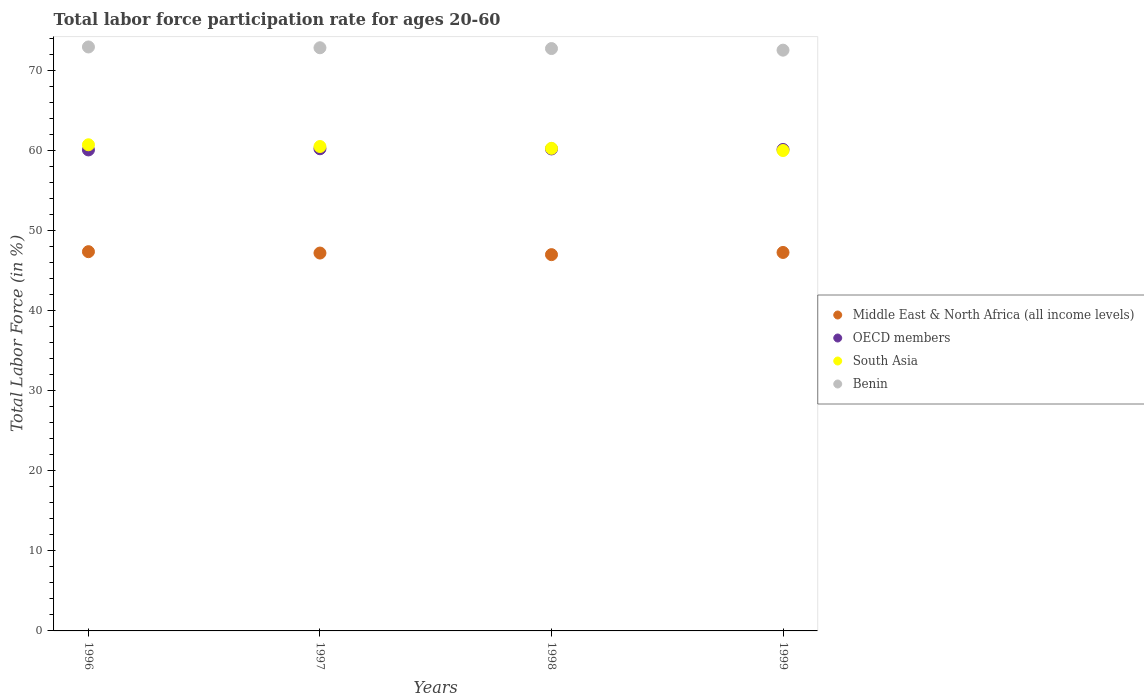What is the labor force participation rate in Middle East & North Africa (all income levels) in 1997?
Offer a very short reply. 47.17. Across all years, what is the maximum labor force participation rate in OECD members?
Your response must be concise. 60.19. Across all years, what is the minimum labor force participation rate in Middle East & North Africa (all income levels)?
Make the answer very short. 46.97. In which year was the labor force participation rate in OECD members maximum?
Ensure brevity in your answer.  1997. What is the total labor force participation rate in Middle East & North Africa (all income levels) in the graph?
Your answer should be very brief. 188.74. What is the difference between the labor force participation rate in Benin in 1996 and that in 1997?
Make the answer very short. 0.1. What is the difference between the labor force participation rate in OECD members in 1997 and the labor force participation rate in Middle East & North Africa (all income levels) in 1999?
Make the answer very short. 12.94. What is the average labor force participation rate in South Asia per year?
Offer a very short reply. 60.34. In the year 1999, what is the difference between the labor force participation rate in OECD members and labor force participation rate in Middle East & North Africa (all income levels)?
Provide a succinct answer. 12.86. In how many years, is the labor force participation rate in Middle East & North Africa (all income levels) greater than 36 %?
Provide a short and direct response. 4. What is the ratio of the labor force participation rate in Benin in 1997 to that in 1998?
Offer a very short reply. 1. Is the labor force participation rate in Middle East & North Africa (all income levels) in 1998 less than that in 1999?
Your response must be concise. Yes. Is the difference between the labor force participation rate in OECD members in 1997 and 1999 greater than the difference between the labor force participation rate in Middle East & North Africa (all income levels) in 1997 and 1999?
Ensure brevity in your answer.  Yes. What is the difference between the highest and the second highest labor force participation rate in Middle East & North Africa (all income levels)?
Your answer should be very brief. 0.1. What is the difference between the highest and the lowest labor force participation rate in Middle East & North Africa (all income levels)?
Provide a short and direct response. 0.37. Is it the case that in every year, the sum of the labor force participation rate in Benin and labor force participation rate in South Asia  is greater than the sum of labor force participation rate in Middle East & North Africa (all income levels) and labor force participation rate in OECD members?
Offer a terse response. Yes. Is it the case that in every year, the sum of the labor force participation rate in South Asia and labor force participation rate in OECD members  is greater than the labor force participation rate in Middle East & North Africa (all income levels)?
Offer a terse response. Yes. Does the labor force participation rate in OECD members monotonically increase over the years?
Keep it short and to the point. No. Is the labor force participation rate in Middle East & North Africa (all income levels) strictly greater than the labor force participation rate in Benin over the years?
Your answer should be very brief. No. Is the labor force participation rate in South Asia strictly less than the labor force participation rate in Middle East & North Africa (all income levels) over the years?
Make the answer very short. No. How many dotlines are there?
Provide a succinct answer. 4. How many years are there in the graph?
Make the answer very short. 4. What is the difference between two consecutive major ticks on the Y-axis?
Give a very brief answer. 10. What is the title of the graph?
Your answer should be compact. Total labor force participation rate for ages 20-60. Does "Bolivia" appear as one of the legend labels in the graph?
Keep it short and to the point. No. What is the label or title of the X-axis?
Offer a terse response. Years. What is the label or title of the Y-axis?
Your response must be concise. Total Labor Force (in %). What is the Total Labor Force (in %) of Middle East & North Africa (all income levels) in 1996?
Your answer should be very brief. 47.34. What is the Total Labor Force (in %) of OECD members in 1996?
Provide a succinct answer. 60.05. What is the Total Labor Force (in %) of South Asia in 1996?
Provide a succinct answer. 60.69. What is the Total Labor Force (in %) of Benin in 1996?
Give a very brief answer. 72.9. What is the Total Labor Force (in %) of Middle East & North Africa (all income levels) in 1997?
Provide a succinct answer. 47.17. What is the Total Labor Force (in %) in OECD members in 1997?
Provide a short and direct response. 60.19. What is the Total Labor Force (in %) of South Asia in 1997?
Your answer should be very brief. 60.47. What is the Total Labor Force (in %) of Benin in 1997?
Give a very brief answer. 72.8. What is the Total Labor Force (in %) in Middle East & North Africa (all income levels) in 1998?
Provide a succinct answer. 46.97. What is the Total Labor Force (in %) of OECD members in 1998?
Your response must be concise. 60.17. What is the Total Labor Force (in %) in South Asia in 1998?
Give a very brief answer. 60.25. What is the Total Labor Force (in %) in Benin in 1998?
Provide a succinct answer. 72.7. What is the Total Labor Force (in %) of Middle East & North Africa (all income levels) in 1999?
Ensure brevity in your answer.  47.25. What is the Total Labor Force (in %) in OECD members in 1999?
Your answer should be very brief. 60.1. What is the Total Labor Force (in %) of South Asia in 1999?
Your answer should be compact. 59.97. What is the Total Labor Force (in %) in Benin in 1999?
Your answer should be very brief. 72.5. Across all years, what is the maximum Total Labor Force (in %) of Middle East & North Africa (all income levels)?
Give a very brief answer. 47.34. Across all years, what is the maximum Total Labor Force (in %) of OECD members?
Give a very brief answer. 60.19. Across all years, what is the maximum Total Labor Force (in %) in South Asia?
Your response must be concise. 60.69. Across all years, what is the maximum Total Labor Force (in %) of Benin?
Offer a terse response. 72.9. Across all years, what is the minimum Total Labor Force (in %) in Middle East & North Africa (all income levels)?
Your answer should be very brief. 46.97. Across all years, what is the minimum Total Labor Force (in %) in OECD members?
Keep it short and to the point. 60.05. Across all years, what is the minimum Total Labor Force (in %) in South Asia?
Your answer should be compact. 59.97. Across all years, what is the minimum Total Labor Force (in %) of Benin?
Keep it short and to the point. 72.5. What is the total Total Labor Force (in %) in Middle East & North Africa (all income levels) in the graph?
Your answer should be compact. 188.74. What is the total Total Labor Force (in %) in OECD members in the graph?
Provide a succinct answer. 240.51. What is the total Total Labor Force (in %) of South Asia in the graph?
Provide a short and direct response. 241.38. What is the total Total Labor Force (in %) in Benin in the graph?
Provide a short and direct response. 290.9. What is the difference between the Total Labor Force (in %) in Middle East & North Africa (all income levels) in 1996 and that in 1997?
Provide a short and direct response. 0.17. What is the difference between the Total Labor Force (in %) of OECD members in 1996 and that in 1997?
Offer a terse response. -0.15. What is the difference between the Total Labor Force (in %) of South Asia in 1996 and that in 1997?
Ensure brevity in your answer.  0.22. What is the difference between the Total Labor Force (in %) in Benin in 1996 and that in 1997?
Your answer should be very brief. 0.1. What is the difference between the Total Labor Force (in %) of Middle East & North Africa (all income levels) in 1996 and that in 1998?
Your response must be concise. 0.37. What is the difference between the Total Labor Force (in %) of OECD members in 1996 and that in 1998?
Your answer should be compact. -0.12. What is the difference between the Total Labor Force (in %) in South Asia in 1996 and that in 1998?
Offer a very short reply. 0.44. What is the difference between the Total Labor Force (in %) in Middle East & North Africa (all income levels) in 1996 and that in 1999?
Your answer should be very brief. 0.1. What is the difference between the Total Labor Force (in %) of OECD members in 1996 and that in 1999?
Offer a terse response. -0.06. What is the difference between the Total Labor Force (in %) in South Asia in 1996 and that in 1999?
Ensure brevity in your answer.  0.72. What is the difference between the Total Labor Force (in %) of Middle East & North Africa (all income levels) in 1997 and that in 1998?
Your answer should be compact. 0.2. What is the difference between the Total Labor Force (in %) of OECD members in 1997 and that in 1998?
Your answer should be very brief. 0.02. What is the difference between the Total Labor Force (in %) of South Asia in 1997 and that in 1998?
Ensure brevity in your answer.  0.23. What is the difference between the Total Labor Force (in %) of Benin in 1997 and that in 1998?
Ensure brevity in your answer.  0.1. What is the difference between the Total Labor Force (in %) of Middle East & North Africa (all income levels) in 1997 and that in 1999?
Your answer should be compact. -0.07. What is the difference between the Total Labor Force (in %) of OECD members in 1997 and that in 1999?
Offer a very short reply. 0.09. What is the difference between the Total Labor Force (in %) in South Asia in 1997 and that in 1999?
Your answer should be compact. 0.5. What is the difference between the Total Labor Force (in %) of Benin in 1997 and that in 1999?
Give a very brief answer. 0.3. What is the difference between the Total Labor Force (in %) of Middle East & North Africa (all income levels) in 1998 and that in 1999?
Your answer should be very brief. -0.27. What is the difference between the Total Labor Force (in %) in OECD members in 1998 and that in 1999?
Give a very brief answer. 0.06. What is the difference between the Total Labor Force (in %) in South Asia in 1998 and that in 1999?
Give a very brief answer. 0.27. What is the difference between the Total Labor Force (in %) of Middle East & North Africa (all income levels) in 1996 and the Total Labor Force (in %) of OECD members in 1997?
Offer a very short reply. -12.85. What is the difference between the Total Labor Force (in %) of Middle East & North Africa (all income levels) in 1996 and the Total Labor Force (in %) of South Asia in 1997?
Provide a succinct answer. -13.13. What is the difference between the Total Labor Force (in %) of Middle East & North Africa (all income levels) in 1996 and the Total Labor Force (in %) of Benin in 1997?
Make the answer very short. -25.46. What is the difference between the Total Labor Force (in %) in OECD members in 1996 and the Total Labor Force (in %) in South Asia in 1997?
Your answer should be compact. -0.43. What is the difference between the Total Labor Force (in %) in OECD members in 1996 and the Total Labor Force (in %) in Benin in 1997?
Your answer should be very brief. -12.75. What is the difference between the Total Labor Force (in %) of South Asia in 1996 and the Total Labor Force (in %) of Benin in 1997?
Make the answer very short. -12.11. What is the difference between the Total Labor Force (in %) of Middle East & North Africa (all income levels) in 1996 and the Total Labor Force (in %) of OECD members in 1998?
Your answer should be very brief. -12.82. What is the difference between the Total Labor Force (in %) in Middle East & North Africa (all income levels) in 1996 and the Total Labor Force (in %) in South Asia in 1998?
Your answer should be very brief. -12.9. What is the difference between the Total Labor Force (in %) of Middle East & North Africa (all income levels) in 1996 and the Total Labor Force (in %) of Benin in 1998?
Your response must be concise. -25.36. What is the difference between the Total Labor Force (in %) in OECD members in 1996 and the Total Labor Force (in %) in South Asia in 1998?
Provide a short and direct response. -0.2. What is the difference between the Total Labor Force (in %) of OECD members in 1996 and the Total Labor Force (in %) of Benin in 1998?
Ensure brevity in your answer.  -12.65. What is the difference between the Total Labor Force (in %) of South Asia in 1996 and the Total Labor Force (in %) of Benin in 1998?
Make the answer very short. -12.01. What is the difference between the Total Labor Force (in %) of Middle East & North Africa (all income levels) in 1996 and the Total Labor Force (in %) of OECD members in 1999?
Offer a very short reply. -12.76. What is the difference between the Total Labor Force (in %) of Middle East & North Africa (all income levels) in 1996 and the Total Labor Force (in %) of South Asia in 1999?
Your answer should be very brief. -12.63. What is the difference between the Total Labor Force (in %) in Middle East & North Africa (all income levels) in 1996 and the Total Labor Force (in %) in Benin in 1999?
Your answer should be very brief. -25.16. What is the difference between the Total Labor Force (in %) of OECD members in 1996 and the Total Labor Force (in %) of South Asia in 1999?
Keep it short and to the point. 0.07. What is the difference between the Total Labor Force (in %) of OECD members in 1996 and the Total Labor Force (in %) of Benin in 1999?
Offer a terse response. -12.45. What is the difference between the Total Labor Force (in %) in South Asia in 1996 and the Total Labor Force (in %) in Benin in 1999?
Your answer should be very brief. -11.81. What is the difference between the Total Labor Force (in %) of Middle East & North Africa (all income levels) in 1997 and the Total Labor Force (in %) of OECD members in 1998?
Your answer should be very brief. -13. What is the difference between the Total Labor Force (in %) in Middle East & North Africa (all income levels) in 1997 and the Total Labor Force (in %) in South Asia in 1998?
Give a very brief answer. -13.07. What is the difference between the Total Labor Force (in %) in Middle East & North Africa (all income levels) in 1997 and the Total Labor Force (in %) in Benin in 1998?
Provide a short and direct response. -25.53. What is the difference between the Total Labor Force (in %) in OECD members in 1997 and the Total Labor Force (in %) in South Asia in 1998?
Your answer should be compact. -0.05. What is the difference between the Total Labor Force (in %) in OECD members in 1997 and the Total Labor Force (in %) in Benin in 1998?
Give a very brief answer. -12.51. What is the difference between the Total Labor Force (in %) in South Asia in 1997 and the Total Labor Force (in %) in Benin in 1998?
Provide a short and direct response. -12.23. What is the difference between the Total Labor Force (in %) in Middle East & North Africa (all income levels) in 1997 and the Total Labor Force (in %) in OECD members in 1999?
Provide a short and direct response. -12.93. What is the difference between the Total Labor Force (in %) in Middle East & North Africa (all income levels) in 1997 and the Total Labor Force (in %) in South Asia in 1999?
Your answer should be very brief. -12.8. What is the difference between the Total Labor Force (in %) of Middle East & North Africa (all income levels) in 1997 and the Total Labor Force (in %) of Benin in 1999?
Provide a short and direct response. -25.33. What is the difference between the Total Labor Force (in %) in OECD members in 1997 and the Total Labor Force (in %) in South Asia in 1999?
Provide a succinct answer. 0.22. What is the difference between the Total Labor Force (in %) in OECD members in 1997 and the Total Labor Force (in %) in Benin in 1999?
Your answer should be very brief. -12.31. What is the difference between the Total Labor Force (in %) of South Asia in 1997 and the Total Labor Force (in %) of Benin in 1999?
Offer a very short reply. -12.03. What is the difference between the Total Labor Force (in %) in Middle East & North Africa (all income levels) in 1998 and the Total Labor Force (in %) in OECD members in 1999?
Keep it short and to the point. -13.13. What is the difference between the Total Labor Force (in %) in Middle East & North Africa (all income levels) in 1998 and the Total Labor Force (in %) in South Asia in 1999?
Offer a very short reply. -13. What is the difference between the Total Labor Force (in %) in Middle East & North Africa (all income levels) in 1998 and the Total Labor Force (in %) in Benin in 1999?
Make the answer very short. -25.53. What is the difference between the Total Labor Force (in %) in OECD members in 1998 and the Total Labor Force (in %) in South Asia in 1999?
Offer a very short reply. 0.2. What is the difference between the Total Labor Force (in %) in OECD members in 1998 and the Total Labor Force (in %) in Benin in 1999?
Offer a terse response. -12.33. What is the difference between the Total Labor Force (in %) of South Asia in 1998 and the Total Labor Force (in %) of Benin in 1999?
Provide a succinct answer. -12.25. What is the average Total Labor Force (in %) of Middle East & North Africa (all income levels) per year?
Offer a terse response. 47.18. What is the average Total Labor Force (in %) in OECD members per year?
Provide a succinct answer. 60.13. What is the average Total Labor Force (in %) of South Asia per year?
Keep it short and to the point. 60.34. What is the average Total Labor Force (in %) in Benin per year?
Offer a terse response. 72.72. In the year 1996, what is the difference between the Total Labor Force (in %) of Middle East & North Africa (all income levels) and Total Labor Force (in %) of OECD members?
Your answer should be compact. -12.7. In the year 1996, what is the difference between the Total Labor Force (in %) in Middle East & North Africa (all income levels) and Total Labor Force (in %) in South Asia?
Keep it short and to the point. -13.34. In the year 1996, what is the difference between the Total Labor Force (in %) of Middle East & North Africa (all income levels) and Total Labor Force (in %) of Benin?
Give a very brief answer. -25.56. In the year 1996, what is the difference between the Total Labor Force (in %) in OECD members and Total Labor Force (in %) in South Asia?
Give a very brief answer. -0.64. In the year 1996, what is the difference between the Total Labor Force (in %) of OECD members and Total Labor Force (in %) of Benin?
Provide a succinct answer. -12.85. In the year 1996, what is the difference between the Total Labor Force (in %) of South Asia and Total Labor Force (in %) of Benin?
Ensure brevity in your answer.  -12.21. In the year 1997, what is the difference between the Total Labor Force (in %) in Middle East & North Africa (all income levels) and Total Labor Force (in %) in OECD members?
Keep it short and to the point. -13.02. In the year 1997, what is the difference between the Total Labor Force (in %) of Middle East & North Africa (all income levels) and Total Labor Force (in %) of South Asia?
Give a very brief answer. -13.3. In the year 1997, what is the difference between the Total Labor Force (in %) in Middle East & North Africa (all income levels) and Total Labor Force (in %) in Benin?
Give a very brief answer. -25.63. In the year 1997, what is the difference between the Total Labor Force (in %) in OECD members and Total Labor Force (in %) in South Asia?
Make the answer very short. -0.28. In the year 1997, what is the difference between the Total Labor Force (in %) in OECD members and Total Labor Force (in %) in Benin?
Make the answer very short. -12.61. In the year 1997, what is the difference between the Total Labor Force (in %) in South Asia and Total Labor Force (in %) in Benin?
Your answer should be compact. -12.33. In the year 1998, what is the difference between the Total Labor Force (in %) in Middle East & North Africa (all income levels) and Total Labor Force (in %) in OECD members?
Provide a short and direct response. -13.2. In the year 1998, what is the difference between the Total Labor Force (in %) in Middle East & North Africa (all income levels) and Total Labor Force (in %) in South Asia?
Keep it short and to the point. -13.27. In the year 1998, what is the difference between the Total Labor Force (in %) in Middle East & North Africa (all income levels) and Total Labor Force (in %) in Benin?
Provide a short and direct response. -25.73. In the year 1998, what is the difference between the Total Labor Force (in %) in OECD members and Total Labor Force (in %) in South Asia?
Offer a terse response. -0.08. In the year 1998, what is the difference between the Total Labor Force (in %) in OECD members and Total Labor Force (in %) in Benin?
Provide a short and direct response. -12.53. In the year 1998, what is the difference between the Total Labor Force (in %) of South Asia and Total Labor Force (in %) of Benin?
Your response must be concise. -12.45. In the year 1999, what is the difference between the Total Labor Force (in %) of Middle East & North Africa (all income levels) and Total Labor Force (in %) of OECD members?
Make the answer very short. -12.86. In the year 1999, what is the difference between the Total Labor Force (in %) in Middle East & North Africa (all income levels) and Total Labor Force (in %) in South Asia?
Provide a succinct answer. -12.72. In the year 1999, what is the difference between the Total Labor Force (in %) of Middle East & North Africa (all income levels) and Total Labor Force (in %) of Benin?
Your answer should be very brief. -25.25. In the year 1999, what is the difference between the Total Labor Force (in %) in OECD members and Total Labor Force (in %) in South Asia?
Provide a succinct answer. 0.13. In the year 1999, what is the difference between the Total Labor Force (in %) of OECD members and Total Labor Force (in %) of Benin?
Keep it short and to the point. -12.4. In the year 1999, what is the difference between the Total Labor Force (in %) in South Asia and Total Labor Force (in %) in Benin?
Ensure brevity in your answer.  -12.53. What is the ratio of the Total Labor Force (in %) of South Asia in 1996 to that in 1997?
Give a very brief answer. 1. What is the ratio of the Total Labor Force (in %) in Benin in 1996 to that in 1997?
Give a very brief answer. 1. What is the ratio of the Total Labor Force (in %) in Middle East & North Africa (all income levels) in 1996 to that in 1998?
Offer a terse response. 1.01. What is the ratio of the Total Labor Force (in %) in OECD members in 1996 to that in 1998?
Offer a terse response. 1. What is the ratio of the Total Labor Force (in %) in South Asia in 1996 to that in 1998?
Keep it short and to the point. 1.01. What is the ratio of the Total Labor Force (in %) in Middle East & North Africa (all income levels) in 1996 to that in 1999?
Offer a very short reply. 1. What is the ratio of the Total Labor Force (in %) of Benin in 1996 to that in 1999?
Offer a very short reply. 1.01. What is the ratio of the Total Labor Force (in %) of South Asia in 1997 to that in 1998?
Provide a short and direct response. 1. What is the ratio of the Total Labor Force (in %) in Middle East & North Africa (all income levels) in 1997 to that in 1999?
Your answer should be compact. 1. What is the ratio of the Total Labor Force (in %) in South Asia in 1997 to that in 1999?
Offer a terse response. 1.01. What is the ratio of the Total Labor Force (in %) of OECD members in 1998 to that in 1999?
Your answer should be very brief. 1. What is the difference between the highest and the second highest Total Labor Force (in %) of Middle East & North Africa (all income levels)?
Your response must be concise. 0.1. What is the difference between the highest and the second highest Total Labor Force (in %) of OECD members?
Your answer should be compact. 0.02. What is the difference between the highest and the second highest Total Labor Force (in %) of South Asia?
Keep it short and to the point. 0.22. What is the difference between the highest and the second highest Total Labor Force (in %) in Benin?
Your response must be concise. 0.1. What is the difference between the highest and the lowest Total Labor Force (in %) in Middle East & North Africa (all income levels)?
Offer a very short reply. 0.37. What is the difference between the highest and the lowest Total Labor Force (in %) of OECD members?
Offer a terse response. 0.15. What is the difference between the highest and the lowest Total Labor Force (in %) of South Asia?
Provide a short and direct response. 0.72. What is the difference between the highest and the lowest Total Labor Force (in %) of Benin?
Make the answer very short. 0.4. 